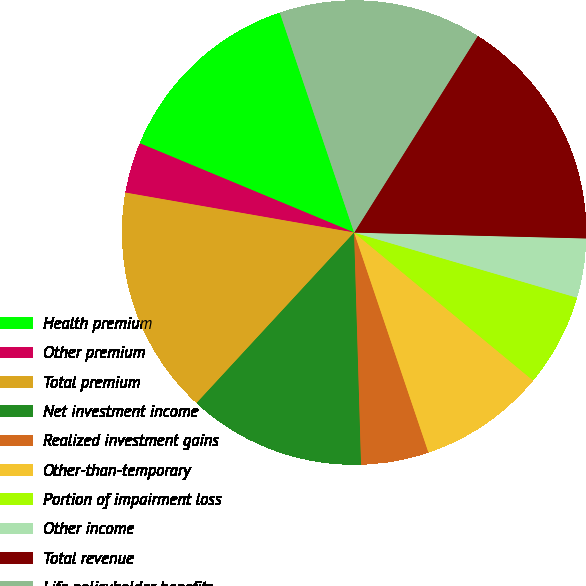Convert chart to OTSL. <chart><loc_0><loc_0><loc_500><loc_500><pie_chart><fcel>Health premium<fcel>Other premium<fcel>Total premium<fcel>Net investment income<fcel>Realized investment gains<fcel>Other-than-temporary<fcel>Portion of impairment loss<fcel>Other income<fcel>Total revenue<fcel>Life policyholder benefits<nl><fcel>13.53%<fcel>3.53%<fcel>15.88%<fcel>12.35%<fcel>4.71%<fcel>8.82%<fcel>6.47%<fcel>4.12%<fcel>16.47%<fcel>14.12%<nl></chart> 